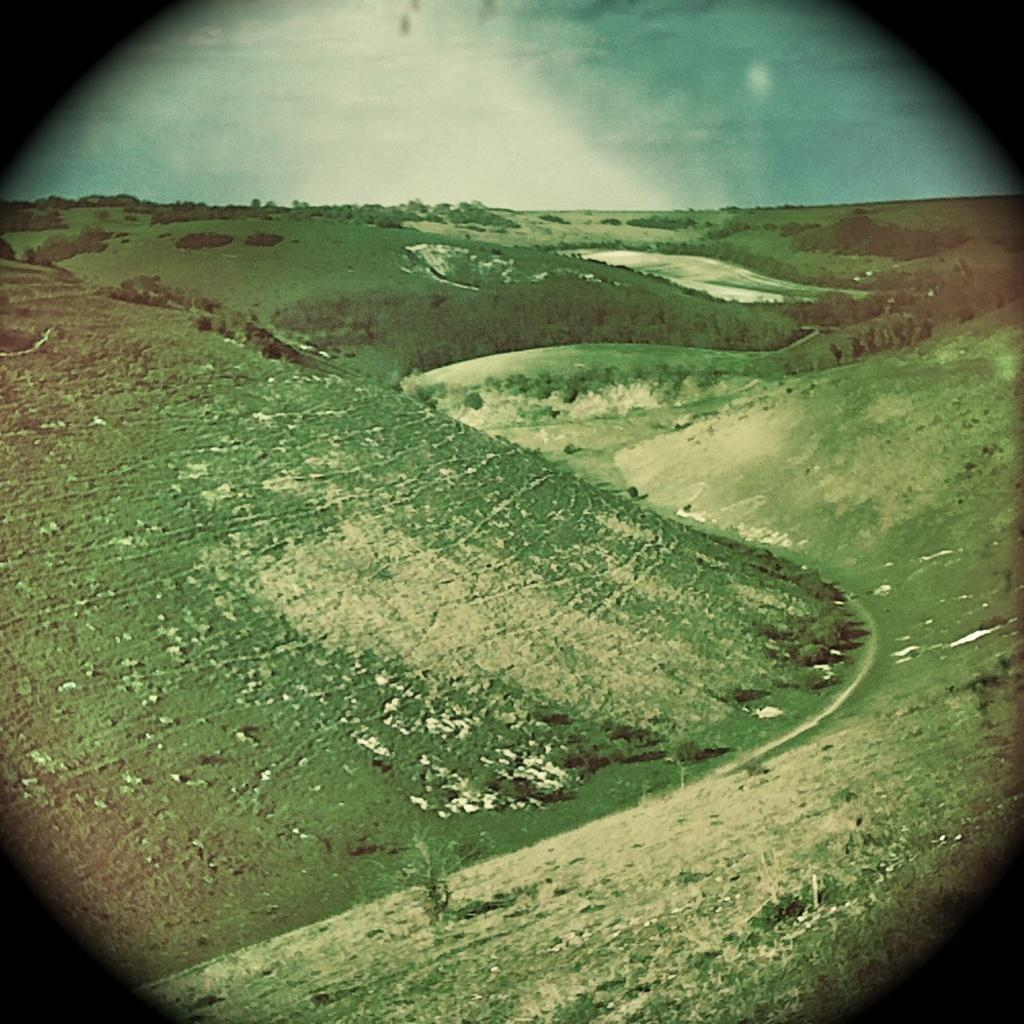What can be observed about the image's appearance? The image appears to be edited. What is visible in the foreground of the image? There is ground and green grass visible in the foreground of the image. What type of vegetation is present in the center of the image? There are plants in the center of the image. What can be seen in the background of the image? There is a sky visible in the background of the image. How many rabbits can be seen hopping on the step in the image? There are no rabbits or steps present in the image. 